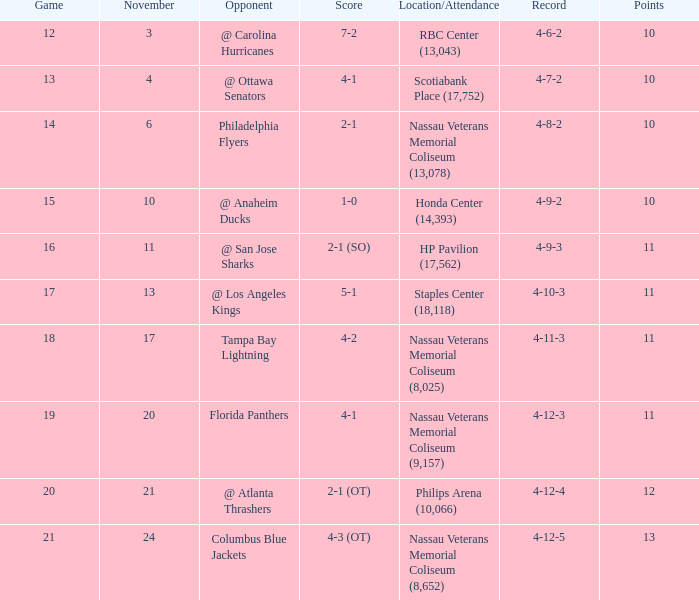What is every record for game 13? 4-7-2. 